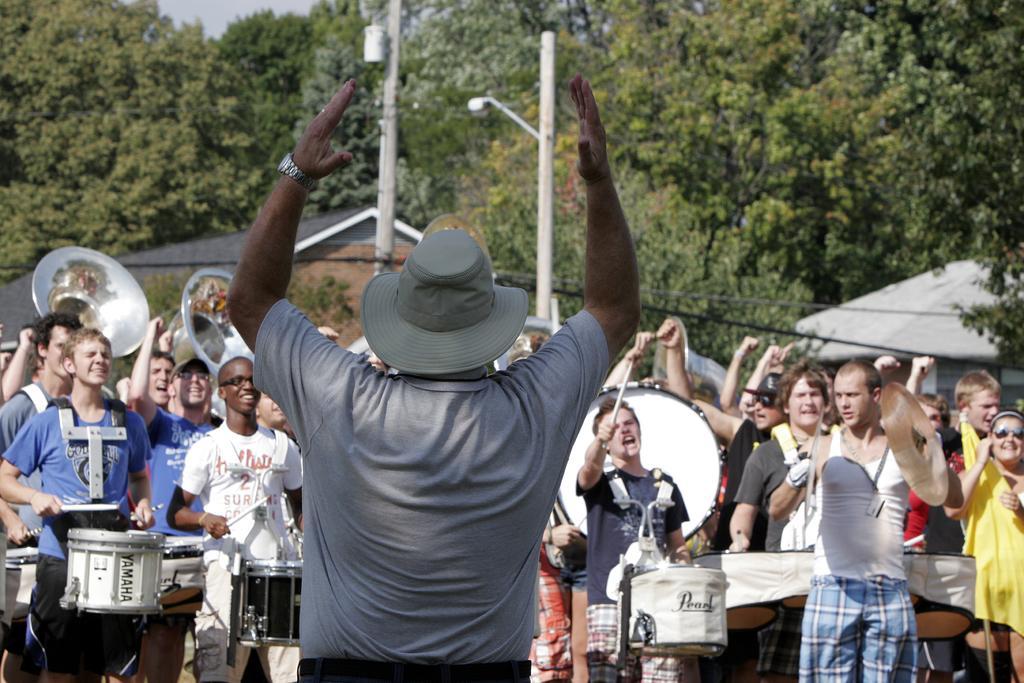Please provide a concise description of this image. In the picture we can see a man standing and raising his hands and he is wearing a T-shirt and a hat and in front of him we can see some people are playing a musical instrument and behind them, we can see some people are raising the hands and behind them we can see some plants, houses, trees and pole with light. 